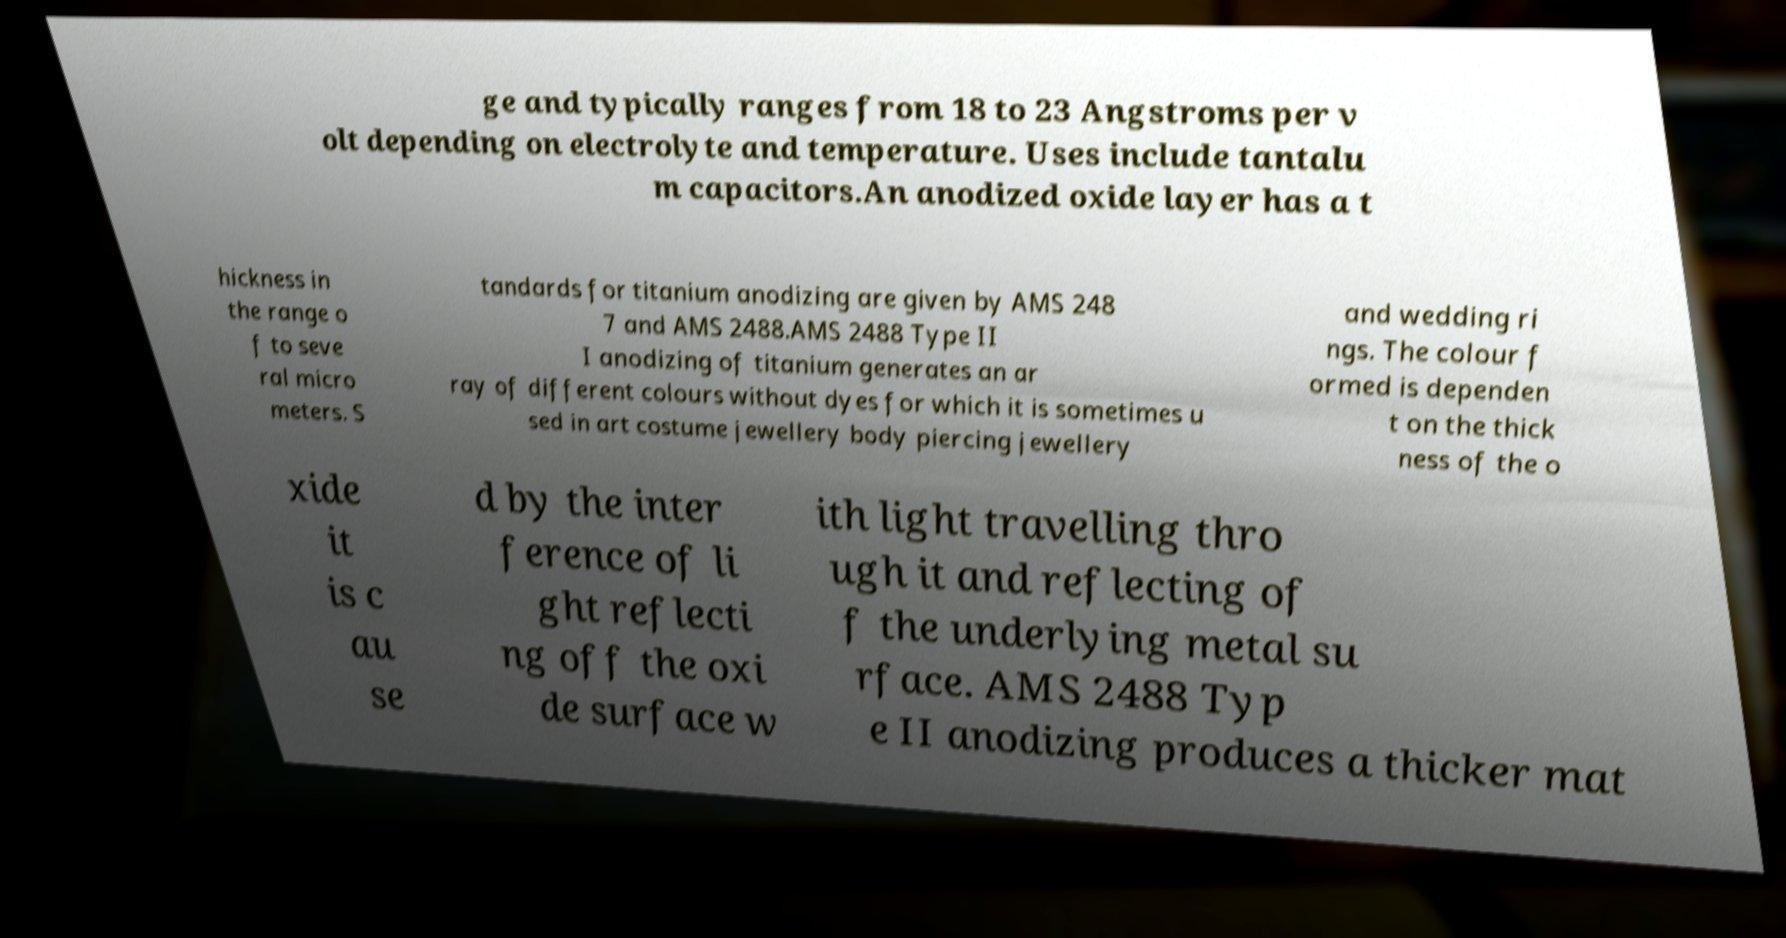Could you extract and type out the text from this image? ge and typically ranges from 18 to 23 Angstroms per v olt depending on electrolyte and temperature. Uses include tantalu m capacitors.An anodized oxide layer has a t hickness in the range o f to seve ral micro meters. S tandards for titanium anodizing are given by AMS 248 7 and AMS 2488.AMS 2488 Type II I anodizing of titanium generates an ar ray of different colours without dyes for which it is sometimes u sed in art costume jewellery body piercing jewellery and wedding ri ngs. The colour f ormed is dependen t on the thick ness of the o xide it is c au se d by the inter ference of li ght reflecti ng off the oxi de surface w ith light travelling thro ugh it and reflecting of f the underlying metal su rface. AMS 2488 Typ e II anodizing produces a thicker mat 